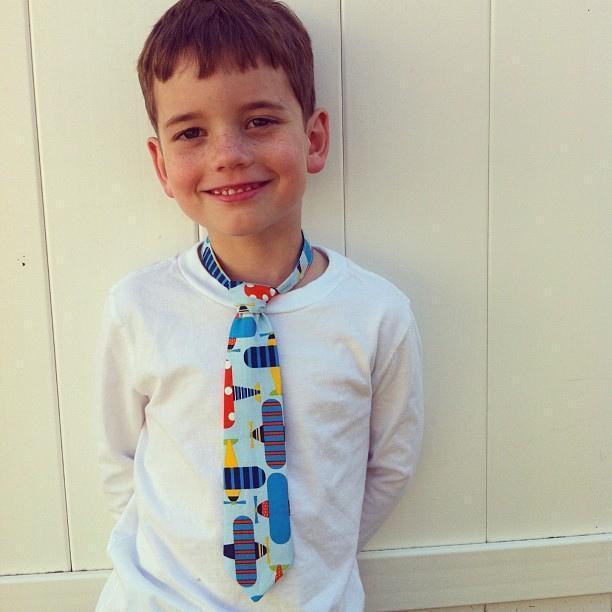How many ties are in the photo?
Give a very brief answer. 1. How many people are visible?
Give a very brief answer. 1. 